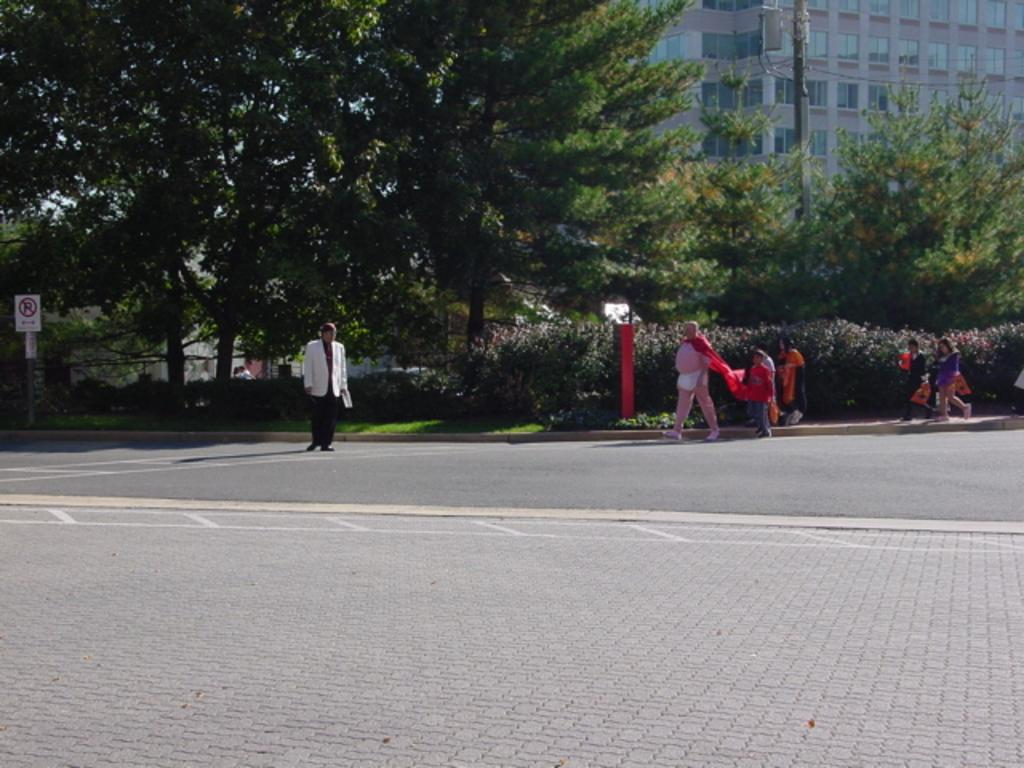What types of living organisms can be seen in the image? People, trees, plants, and grass are visible in the image. What type of structures are present in the image? Buildings and a sign board are present in the image. What architectural features can be seen in the image? Windows and poles are visible in the image. What is the primary mode of transportation in the image? There is a road in the image, which suggests that vehicles might be used for transportation. Can you tell me how many mint leaves are on the sign board in the image? There are no mint leaves present on the sign board in the image. What type of back is visible on the people in the image? There is no specific back visible on the people in the image, as they are not shown in a way that highlights their backs. 